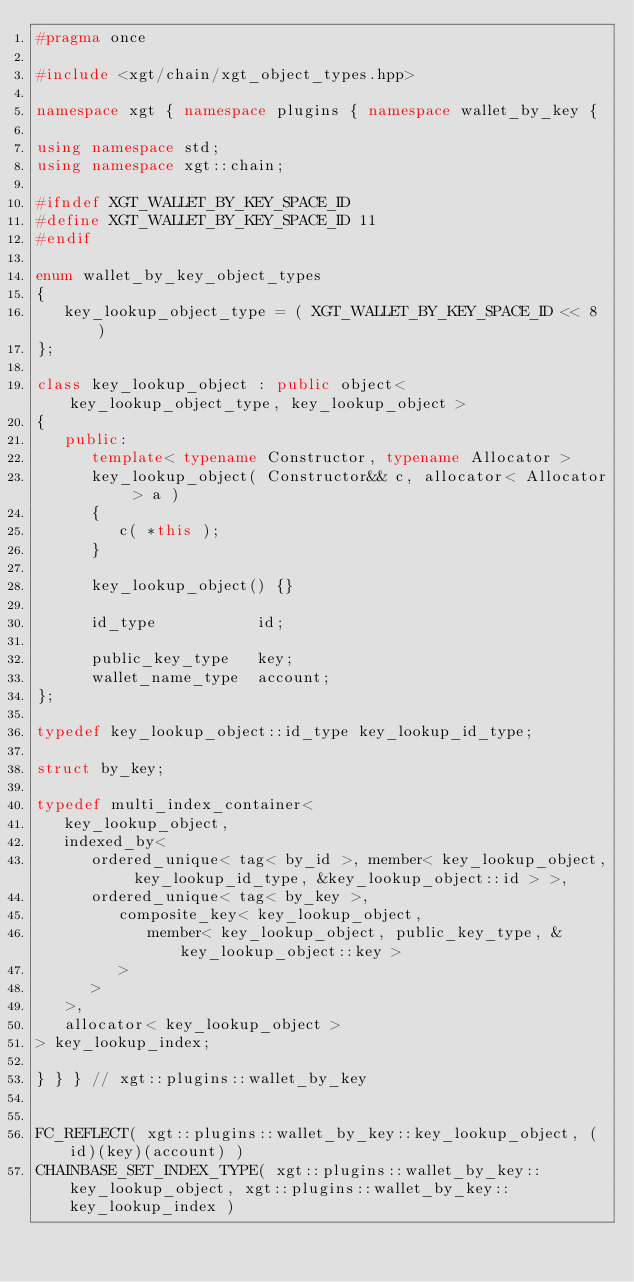<code> <loc_0><loc_0><loc_500><loc_500><_C++_>#pragma once

#include <xgt/chain/xgt_object_types.hpp>

namespace xgt { namespace plugins { namespace wallet_by_key {

using namespace std;
using namespace xgt::chain;

#ifndef XGT_WALLET_BY_KEY_SPACE_ID
#define XGT_WALLET_BY_KEY_SPACE_ID 11
#endif

enum wallet_by_key_object_types
{
   key_lookup_object_type = ( XGT_WALLET_BY_KEY_SPACE_ID << 8 )
};

class key_lookup_object : public object< key_lookup_object_type, key_lookup_object >
{
   public:
      template< typename Constructor, typename Allocator >
      key_lookup_object( Constructor&& c, allocator< Allocator > a )
      {
         c( *this );
      }

      key_lookup_object() {}

      id_type           id;

      public_key_type   key;
      wallet_name_type  account;
};

typedef key_lookup_object::id_type key_lookup_id_type;

struct by_key;

typedef multi_index_container<
   key_lookup_object,
   indexed_by<
      ordered_unique< tag< by_id >, member< key_lookup_object, key_lookup_id_type, &key_lookup_object::id > >,
      ordered_unique< tag< by_key >,
         composite_key< key_lookup_object,
            member< key_lookup_object, public_key_type, &key_lookup_object::key >
         >
      >
   >,
   allocator< key_lookup_object >
> key_lookup_index;

} } } // xgt::plugins::wallet_by_key


FC_REFLECT( xgt::plugins::wallet_by_key::key_lookup_object, (id)(key)(account) )
CHAINBASE_SET_INDEX_TYPE( xgt::plugins::wallet_by_key::key_lookup_object, xgt::plugins::wallet_by_key::key_lookup_index )
</code> 